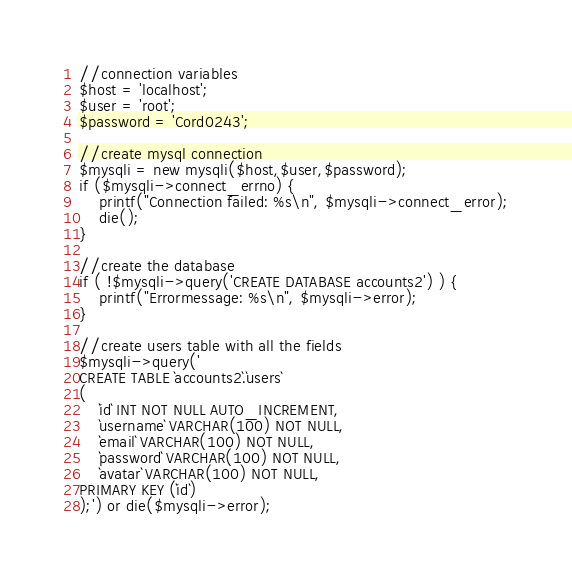Convert code to text. <code><loc_0><loc_0><loc_500><loc_500><_SQL_>//connection variables
$host = 'localhost';
$user = 'root';
$password = 'Cord0243';

//create mysql connection
$mysqli = new mysqli($host,$user,$password);
if ($mysqli->connect_errno) {
    printf("Connection failed: %s\n", $mysqli->connect_error);
    die();
}

//create the database
if ( !$mysqli->query('CREATE DATABASE accounts2') ) {
    printf("Errormessage: %s\n", $mysqli->error);
}

//create users table with all the fields
$mysqli->query('
CREATE TABLE `accounts2`.`users` 
(
    `id` INT NOT NULL AUTO_INCREMENT,
    `username` VARCHAR(100) NOT NULL,
    `email` VARCHAR(100) NOT NULL,
    `password` VARCHAR(100) NOT NULL,
    `avatar` VARCHAR(100) NOT NULL,
PRIMARY KEY (`id`) 
);') or die($mysqli->error);
</code> 